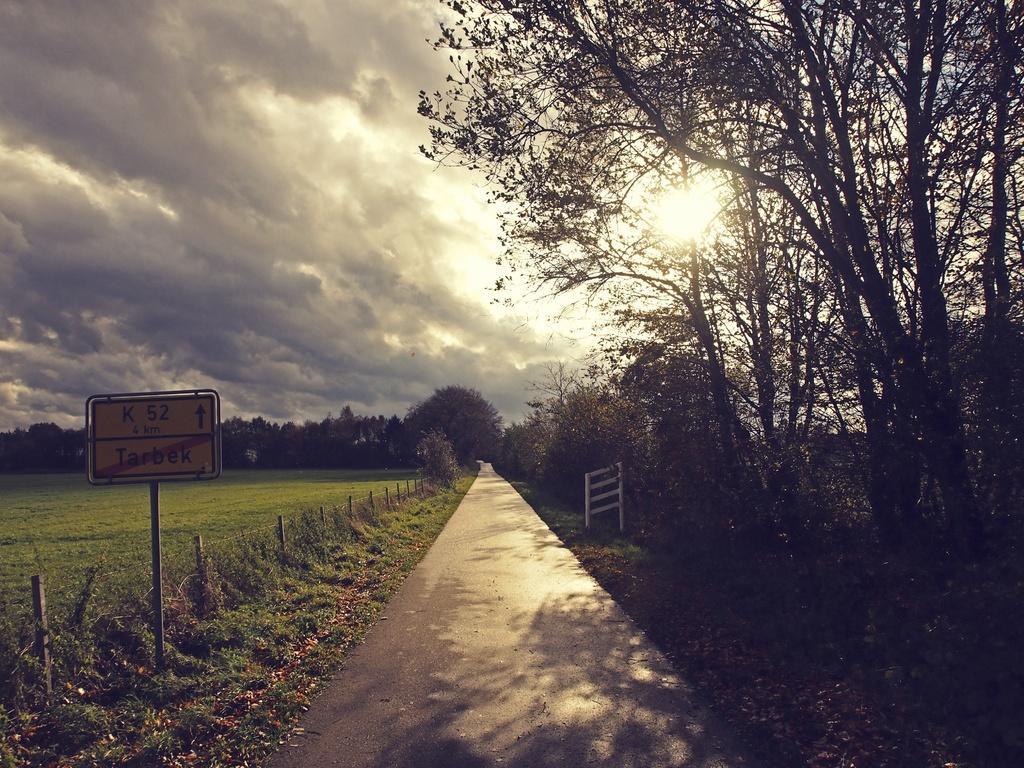How would you summarize this image in a sentence or two? This image consists of many trees. At the bottom, there is a road. On the right, there is a stand. On the left, there is a board. At the top, there are clouds in the sky. 